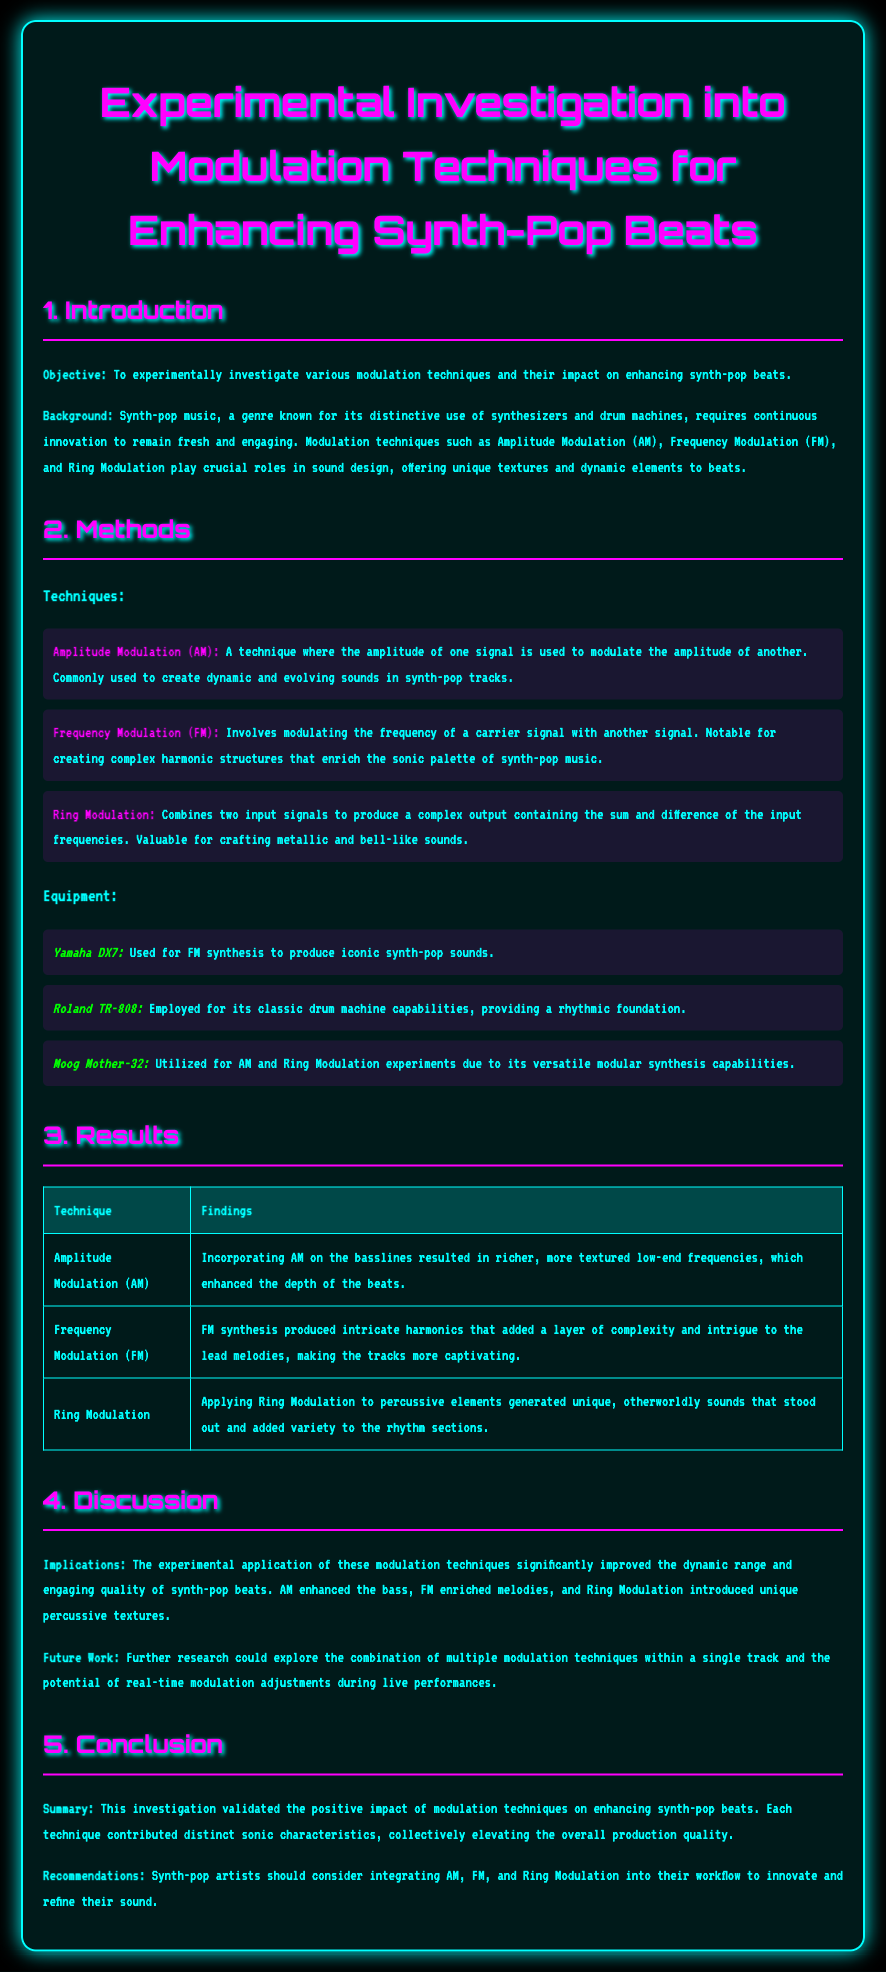What is the objective of the investigation? The objective is to experimentally investigate various modulation techniques and their impact on enhancing synth-pop beats.
Answer: To experimentally investigate various modulation techniques and their impact on enhancing synth-pop beats Which modulation technique is known for creating dynamic sounds? The technique used for creating dynamic and evolving sounds in synth-pop tracks is Amplitude Modulation.
Answer: Amplitude Modulation (AM) What equipment was used for FM synthesis? The equipment specifically used for FM synthesis to produce iconic synth-pop sounds is the Yamaha DX7.
Answer: Yamaha DX7 What was a finding for Frequency Modulation? The finding states that FM synthesis produced intricate harmonics that added a layer of complexity and intrigue to the lead melodies.
Answer: Intricate harmonics added complexity to lead melodies What is mentioned as a future research direction? Future work could explore the combination of multiple modulation techniques within a single track.
Answer: Combination of multiple modulation techniques What modulation technique is associated with metallic sounds? Ring Modulation is known for crafting metallic and bell-like sounds.
Answer: Ring Modulation What color is the background of the document? The background color of the document is black.
Answer: Black How many modulation techniques are discussed in the report? The report discusses three modulation techniques: AM, FM, and Ring Modulation.
Answer: Three 